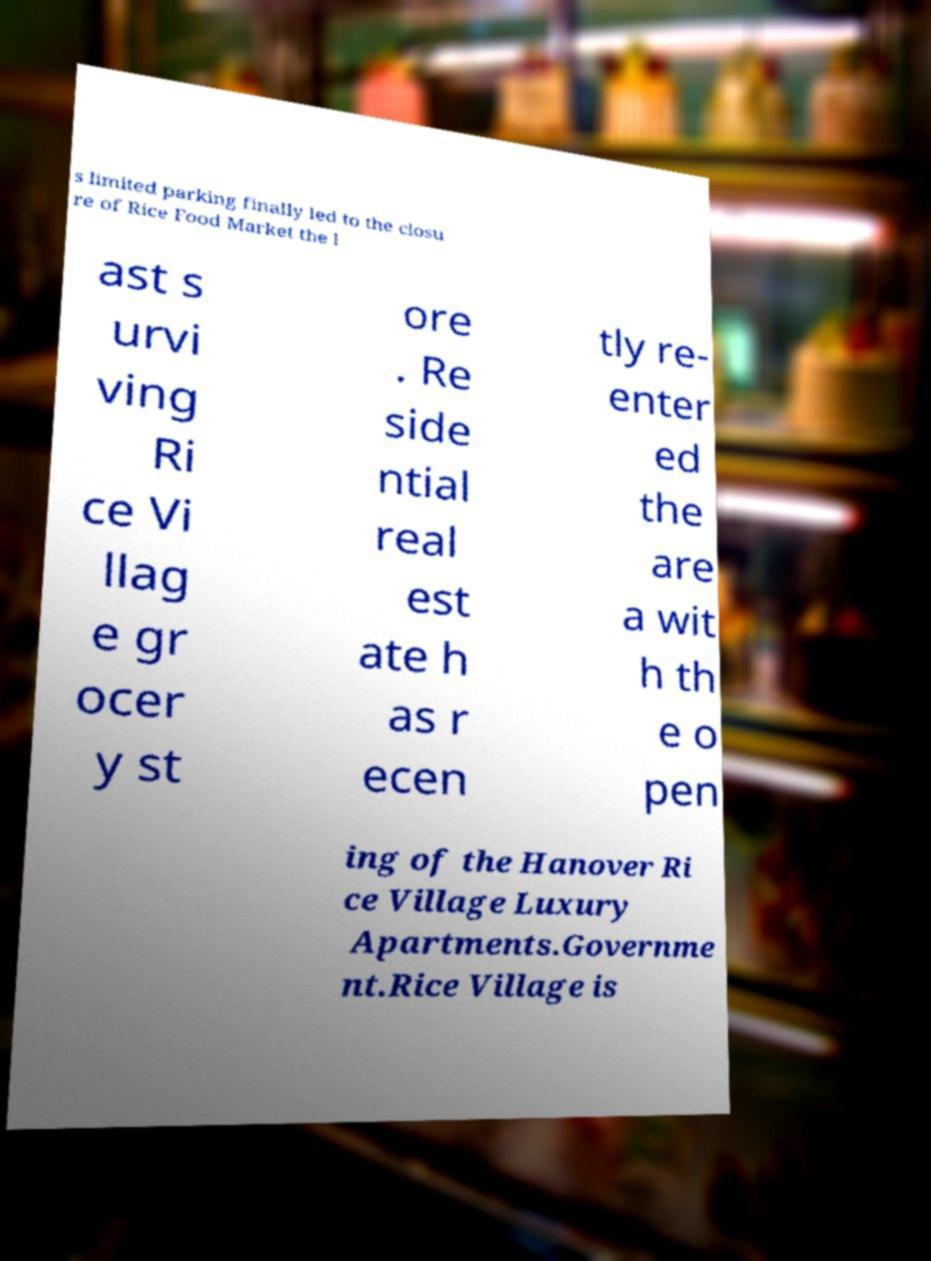Could you assist in decoding the text presented in this image and type it out clearly? s limited parking finally led to the closu re of Rice Food Market the l ast s urvi ving Ri ce Vi llag e gr ocer y st ore . Re side ntial real est ate h as r ecen tly re- enter ed the are a wit h th e o pen ing of the Hanover Ri ce Village Luxury Apartments.Governme nt.Rice Village is 